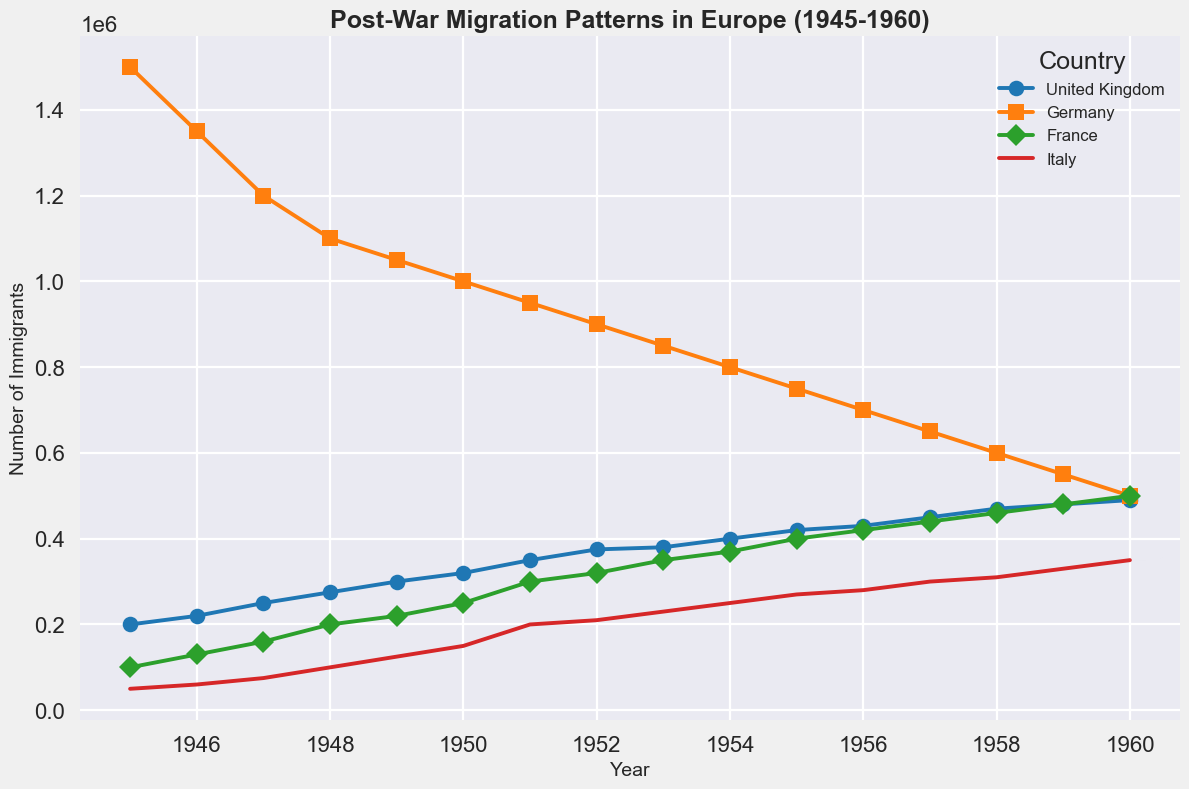Which country had the highest number of immigrants in 1945? In 1945, Germany is represented with a marker in the figure having the highest point among all countries on the y-axis.
Answer: Germany How did the number of immigrants to the United Kingdom change from 1948 to 1950? To find the change, locate the points for the UK in 1948 and 1950 on the graph, and see how the y-values (number of immigrants) differ. In 1948, the UK had 275,000 immigrants, and in 1950, it had 320,000. The change is 320,000 - 275,000.
Answer: Increase by 45,000 Which country saw the most significant decrease in the number of immigrants from 1945 to 1960? Observe the overall trend lines for each country from 1945 to 1960. Germany's trend line shows the steepest decline, going from 1,500,000 in 1945 to 500,000 in 1960.
Answer: Germany What was the total number of immigrants to France from 1945 to 1960? Sum the number of immigrants for France from each year on the graph from 1945 to 1960.
Answer: 4,270,000 Between 1945 and 1960, in which years did Italy surpass 200,000 immigrants? Look at the trend line for Italy and identify the years where the y-value exceeds 200,000. These years are 1951 onwards.
Answer: 1951-1960 By how much did the number of immigrants to France change from 1952 to 1956? Check the y-values for France in 1952 and 1956 on the graph. In 1952, France had 320,000 immigrants, and in 1956, it had 420,000. The change is 420,000 - 320,000.
Answer: Increase by 100,000 Which country had the smallest increase in the number of immigrants between 1945 and 1960? Compare the starting and ending points for each country on the graph from 1945 to 1960. France starts at 100,000 and ends at 500,000, an increase of 400,000. Italy had a smaller increase: from 50,000 to 350,000, an increase of 300,000.
Answer: Italy What was the average number of immigrants to Germany between 1945 and 1960? Sum the number of immigrants for Germany from each year between 1945 and 1960, and then divide by the number of years (16).
Answer: 897,500 